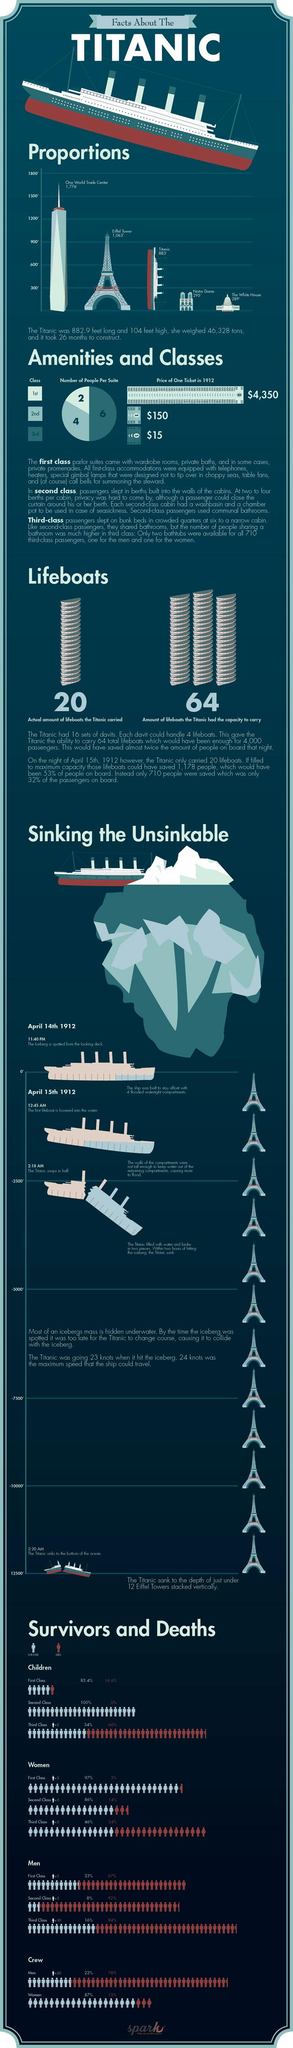List a handful of essential elements in this visual. The Eiffel Tower is longer than the Titanic, as depicted in the graph. The third class suite could accommodate a maximum of six people. The maximum speed allowed for the Titanic was different from the speed at which the ship actually traveled. Specifically, the maximum speed of the Titanic was 24 knots, while the ship's actual speed during its final voyage was 22 knots. The Titanic could have carried 44 more lifeboats. The price difference between a second-class and third-class train ticket was 135. 